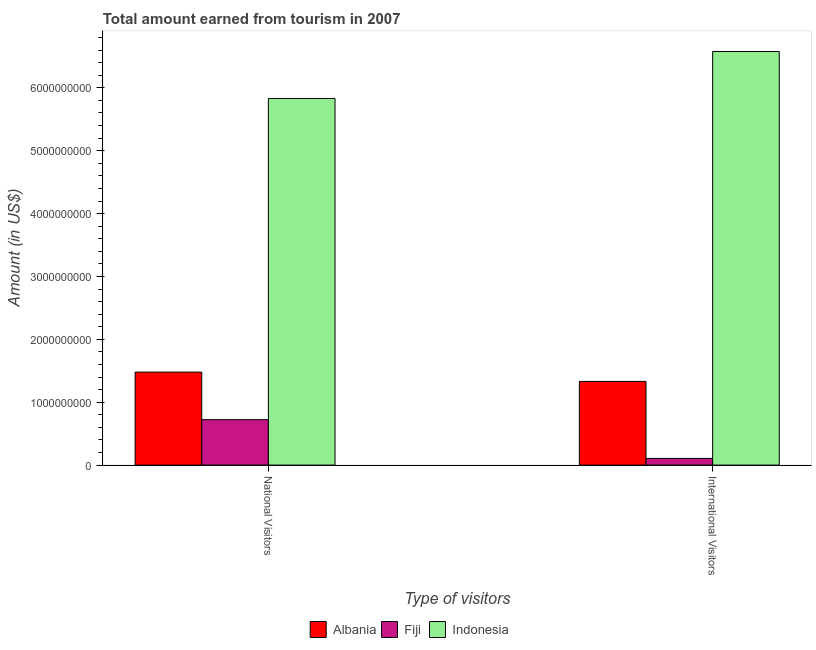How many groups of bars are there?
Your response must be concise. 2. Are the number of bars per tick equal to the number of legend labels?
Your response must be concise. Yes. Are the number of bars on each tick of the X-axis equal?
Provide a succinct answer. Yes. How many bars are there on the 1st tick from the left?
Offer a very short reply. 3. What is the label of the 2nd group of bars from the left?
Keep it short and to the point. International Visitors. What is the amount earned from national visitors in Albania?
Your response must be concise. 1.48e+09. Across all countries, what is the maximum amount earned from national visitors?
Give a very brief answer. 5.83e+09. Across all countries, what is the minimum amount earned from international visitors?
Provide a succinct answer. 1.06e+08. In which country was the amount earned from international visitors minimum?
Ensure brevity in your answer.  Fiji. What is the total amount earned from international visitors in the graph?
Give a very brief answer. 8.02e+09. What is the difference between the amount earned from international visitors in Indonesia and that in Fiji?
Provide a succinct answer. 6.47e+09. What is the difference between the amount earned from national visitors in Fiji and the amount earned from international visitors in Indonesia?
Give a very brief answer. -5.86e+09. What is the average amount earned from national visitors per country?
Offer a very short reply. 2.68e+09. What is the difference between the amount earned from national visitors and amount earned from international visitors in Indonesia?
Offer a terse response. -7.47e+08. In how many countries, is the amount earned from national visitors greater than 5400000000 US$?
Make the answer very short. 1. What is the ratio of the amount earned from international visitors in Indonesia to that in Albania?
Provide a short and direct response. 4.94. Is the amount earned from national visitors in Albania less than that in Indonesia?
Provide a succinct answer. Yes. What does the 2nd bar from the left in International Visitors represents?
Make the answer very short. Fiji. What does the 2nd bar from the right in International Visitors represents?
Your response must be concise. Fiji. How many bars are there?
Offer a very short reply. 6. Are all the bars in the graph horizontal?
Ensure brevity in your answer.  No. How many countries are there in the graph?
Your answer should be very brief. 3. What is the difference between two consecutive major ticks on the Y-axis?
Offer a terse response. 1.00e+09. Are the values on the major ticks of Y-axis written in scientific E-notation?
Your answer should be very brief. No. Does the graph contain any zero values?
Give a very brief answer. No. Does the graph contain grids?
Offer a terse response. No. Where does the legend appear in the graph?
Keep it short and to the point. Bottom center. How are the legend labels stacked?
Provide a succinct answer. Horizontal. What is the title of the graph?
Make the answer very short. Total amount earned from tourism in 2007. What is the label or title of the X-axis?
Ensure brevity in your answer.  Type of visitors. What is the Amount (in US$) of Albania in National Visitors?
Make the answer very short. 1.48e+09. What is the Amount (in US$) of Fiji in National Visitors?
Your answer should be compact. 7.22e+08. What is the Amount (in US$) of Indonesia in National Visitors?
Offer a very short reply. 5.83e+09. What is the Amount (in US$) in Albania in International Visitors?
Your answer should be compact. 1.33e+09. What is the Amount (in US$) in Fiji in International Visitors?
Give a very brief answer. 1.06e+08. What is the Amount (in US$) of Indonesia in International Visitors?
Make the answer very short. 6.58e+09. Across all Type of visitors, what is the maximum Amount (in US$) of Albania?
Offer a terse response. 1.48e+09. Across all Type of visitors, what is the maximum Amount (in US$) in Fiji?
Provide a short and direct response. 7.22e+08. Across all Type of visitors, what is the maximum Amount (in US$) in Indonesia?
Your response must be concise. 6.58e+09. Across all Type of visitors, what is the minimum Amount (in US$) of Albania?
Provide a short and direct response. 1.33e+09. Across all Type of visitors, what is the minimum Amount (in US$) of Fiji?
Keep it short and to the point. 1.06e+08. Across all Type of visitors, what is the minimum Amount (in US$) of Indonesia?
Give a very brief answer. 5.83e+09. What is the total Amount (in US$) in Albania in the graph?
Give a very brief answer. 2.81e+09. What is the total Amount (in US$) of Fiji in the graph?
Ensure brevity in your answer.  8.28e+08. What is the total Amount (in US$) of Indonesia in the graph?
Keep it short and to the point. 1.24e+1. What is the difference between the Amount (in US$) of Albania in National Visitors and that in International Visitors?
Keep it short and to the point. 1.48e+08. What is the difference between the Amount (in US$) of Fiji in National Visitors and that in International Visitors?
Keep it short and to the point. 6.16e+08. What is the difference between the Amount (in US$) in Indonesia in National Visitors and that in International Visitors?
Your response must be concise. -7.47e+08. What is the difference between the Amount (in US$) in Albania in National Visitors and the Amount (in US$) in Fiji in International Visitors?
Your answer should be compact. 1.37e+09. What is the difference between the Amount (in US$) of Albania in National Visitors and the Amount (in US$) of Indonesia in International Visitors?
Provide a short and direct response. -5.10e+09. What is the difference between the Amount (in US$) of Fiji in National Visitors and the Amount (in US$) of Indonesia in International Visitors?
Provide a short and direct response. -5.86e+09. What is the average Amount (in US$) in Albania per Type of visitors?
Your answer should be very brief. 1.40e+09. What is the average Amount (in US$) in Fiji per Type of visitors?
Provide a short and direct response. 4.14e+08. What is the average Amount (in US$) in Indonesia per Type of visitors?
Ensure brevity in your answer.  6.20e+09. What is the difference between the Amount (in US$) in Albania and Amount (in US$) in Fiji in National Visitors?
Your answer should be compact. 7.57e+08. What is the difference between the Amount (in US$) of Albania and Amount (in US$) of Indonesia in National Visitors?
Keep it short and to the point. -4.35e+09. What is the difference between the Amount (in US$) of Fiji and Amount (in US$) of Indonesia in National Visitors?
Provide a short and direct response. -5.11e+09. What is the difference between the Amount (in US$) of Albania and Amount (in US$) of Fiji in International Visitors?
Offer a terse response. 1.22e+09. What is the difference between the Amount (in US$) of Albania and Amount (in US$) of Indonesia in International Visitors?
Give a very brief answer. -5.25e+09. What is the difference between the Amount (in US$) in Fiji and Amount (in US$) in Indonesia in International Visitors?
Your answer should be compact. -6.47e+09. What is the ratio of the Amount (in US$) of Albania in National Visitors to that in International Visitors?
Your response must be concise. 1.11. What is the ratio of the Amount (in US$) of Fiji in National Visitors to that in International Visitors?
Your answer should be compact. 6.81. What is the ratio of the Amount (in US$) of Indonesia in National Visitors to that in International Visitors?
Keep it short and to the point. 0.89. What is the difference between the highest and the second highest Amount (in US$) in Albania?
Offer a terse response. 1.48e+08. What is the difference between the highest and the second highest Amount (in US$) of Fiji?
Make the answer very short. 6.16e+08. What is the difference between the highest and the second highest Amount (in US$) of Indonesia?
Provide a succinct answer. 7.47e+08. What is the difference between the highest and the lowest Amount (in US$) of Albania?
Ensure brevity in your answer.  1.48e+08. What is the difference between the highest and the lowest Amount (in US$) of Fiji?
Provide a succinct answer. 6.16e+08. What is the difference between the highest and the lowest Amount (in US$) of Indonesia?
Your answer should be very brief. 7.47e+08. 